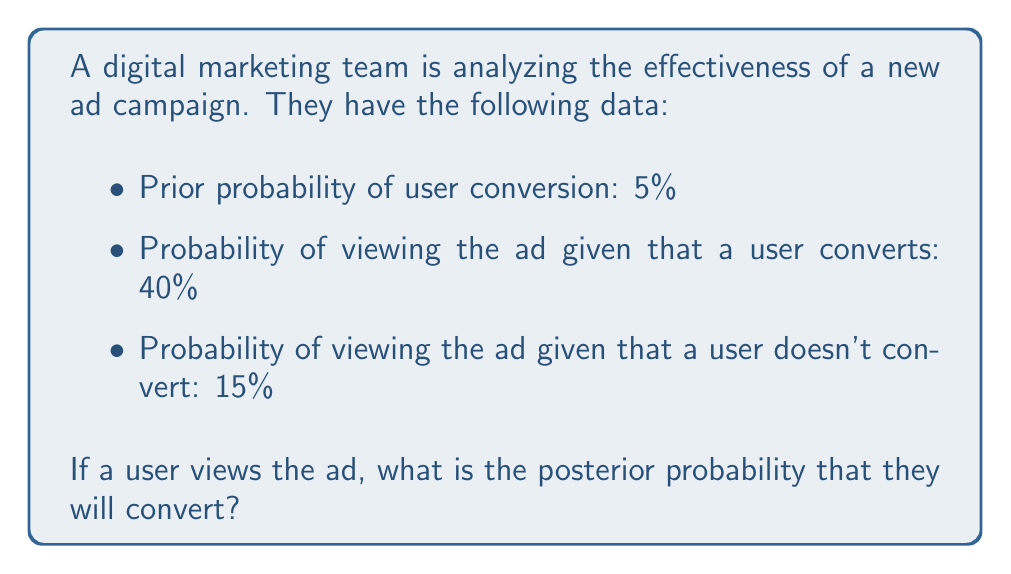Can you solve this math problem? To solve this problem, we'll use Bayes' Theorem:

$$ P(A|B) = \frac{P(B|A) \cdot P(A)}{P(B)} $$

Where:
A = User converts
B = User views the ad

Given:
$P(A) = 0.05$ (prior probability of conversion)
$P(B|A) = 0.40$ (probability of viewing ad given conversion)
$P(B|\text{not }A) = 0.15$ (probability of viewing ad given no conversion)

Step 1: Calculate $P(B)$ using the law of total probability:
$$ P(B) = P(B|A) \cdot P(A) + P(B|\text{not }A) \cdot P(\text{not }A) $$
$$ P(B) = 0.40 \cdot 0.05 + 0.15 \cdot 0.95 = 0.02 + 0.1425 = 0.1625 $$

Step 2: Apply Bayes' Theorem:
$$ P(A|B) = \frac{P(B|A) \cdot P(A)}{P(B)} $$
$$ P(A|B) = \frac{0.40 \cdot 0.05}{0.1625} = \frac{0.02}{0.1625} \approx 0.1231 $$

Therefore, the posterior probability of a user converting after viewing the ad is approximately 12.31%.
Answer: The posterior probability that a user will convert after viewing the ad is approximately 12.31% or 0.1231. 